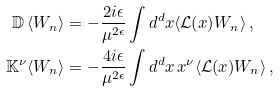<formula> <loc_0><loc_0><loc_500><loc_500>\mathbb { D } \, \langle W _ { n } \rangle & = - \frac { 2 i \epsilon } { \mu ^ { 2 \epsilon } } \int d ^ { d } x \langle \mathcal { L } ( x ) W _ { n } \rangle \, , \\ \mathbb { K } ^ { \nu } \langle W _ { n } \rangle & = - \frac { 4 i \epsilon } { \mu ^ { 2 \epsilon } } \int d ^ { d } x \, x ^ { \nu } \langle \mathcal { L } ( x ) W _ { n } \rangle \, ,</formula> 